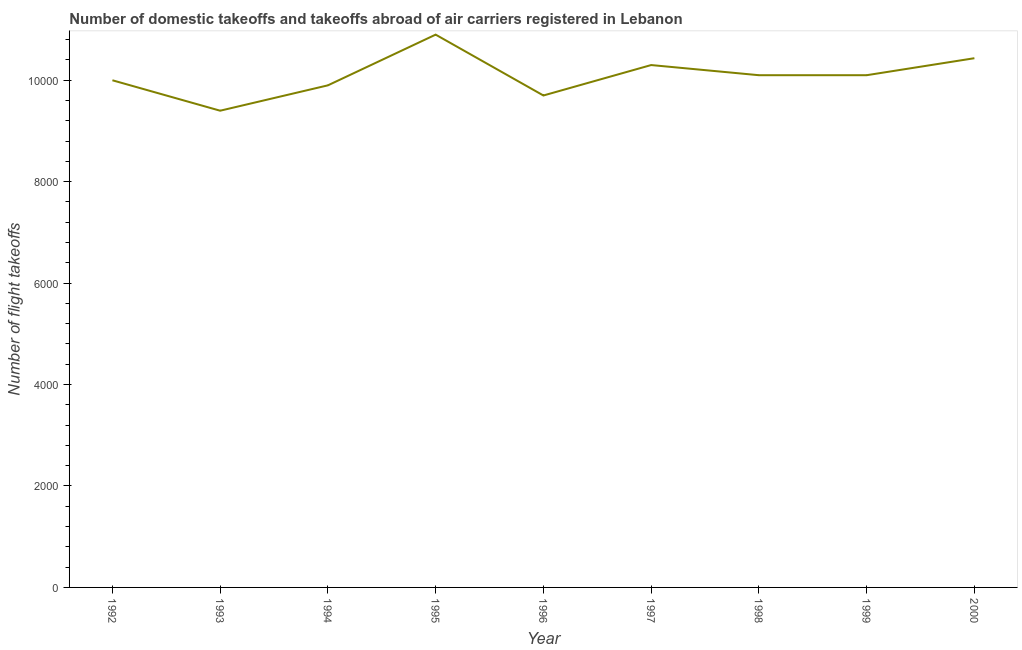What is the number of flight takeoffs in 2000?
Provide a short and direct response. 1.04e+04. Across all years, what is the maximum number of flight takeoffs?
Keep it short and to the point. 1.09e+04. Across all years, what is the minimum number of flight takeoffs?
Ensure brevity in your answer.  9400. In which year was the number of flight takeoffs maximum?
Give a very brief answer. 1995. In which year was the number of flight takeoffs minimum?
Ensure brevity in your answer.  1993. What is the sum of the number of flight takeoffs?
Your response must be concise. 9.08e+04. What is the difference between the number of flight takeoffs in 1993 and 1995?
Keep it short and to the point. -1500. What is the average number of flight takeoffs per year?
Make the answer very short. 1.01e+04. What is the median number of flight takeoffs?
Ensure brevity in your answer.  1.01e+04. Do a majority of the years between 1994 and 1992 (inclusive) have number of flight takeoffs greater than 8800 ?
Your answer should be compact. No. What is the ratio of the number of flight takeoffs in 1996 to that in 1998?
Make the answer very short. 0.96. Is the difference between the number of flight takeoffs in 1995 and 1997 greater than the difference between any two years?
Make the answer very short. No. What is the difference between the highest and the second highest number of flight takeoffs?
Ensure brevity in your answer.  465. Is the sum of the number of flight takeoffs in 1996 and 1999 greater than the maximum number of flight takeoffs across all years?
Keep it short and to the point. Yes. What is the difference between the highest and the lowest number of flight takeoffs?
Your response must be concise. 1500. Does the number of flight takeoffs monotonically increase over the years?
Offer a terse response. No. Are the values on the major ticks of Y-axis written in scientific E-notation?
Your answer should be compact. No. Does the graph contain any zero values?
Give a very brief answer. No. Does the graph contain grids?
Your answer should be compact. No. What is the title of the graph?
Provide a short and direct response. Number of domestic takeoffs and takeoffs abroad of air carriers registered in Lebanon. What is the label or title of the Y-axis?
Ensure brevity in your answer.  Number of flight takeoffs. What is the Number of flight takeoffs in 1993?
Provide a succinct answer. 9400. What is the Number of flight takeoffs of 1994?
Ensure brevity in your answer.  9900. What is the Number of flight takeoffs in 1995?
Keep it short and to the point. 1.09e+04. What is the Number of flight takeoffs in 1996?
Offer a very short reply. 9700. What is the Number of flight takeoffs of 1997?
Keep it short and to the point. 1.03e+04. What is the Number of flight takeoffs in 1998?
Provide a succinct answer. 1.01e+04. What is the Number of flight takeoffs in 1999?
Your answer should be compact. 1.01e+04. What is the Number of flight takeoffs of 2000?
Provide a short and direct response. 1.04e+04. What is the difference between the Number of flight takeoffs in 1992 and 1993?
Offer a terse response. 600. What is the difference between the Number of flight takeoffs in 1992 and 1995?
Give a very brief answer. -900. What is the difference between the Number of flight takeoffs in 1992 and 1996?
Provide a short and direct response. 300. What is the difference between the Number of flight takeoffs in 1992 and 1997?
Your answer should be very brief. -300. What is the difference between the Number of flight takeoffs in 1992 and 1998?
Make the answer very short. -100. What is the difference between the Number of flight takeoffs in 1992 and 1999?
Ensure brevity in your answer.  -100. What is the difference between the Number of flight takeoffs in 1992 and 2000?
Provide a short and direct response. -435. What is the difference between the Number of flight takeoffs in 1993 and 1994?
Give a very brief answer. -500. What is the difference between the Number of flight takeoffs in 1993 and 1995?
Make the answer very short. -1500. What is the difference between the Number of flight takeoffs in 1993 and 1996?
Give a very brief answer. -300. What is the difference between the Number of flight takeoffs in 1993 and 1997?
Offer a very short reply. -900. What is the difference between the Number of flight takeoffs in 1993 and 1998?
Offer a very short reply. -700. What is the difference between the Number of flight takeoffs in 1993 and 1999?
Your answer should be compact. -700. What is the difference between the Number of flight takeoffs in 1993 and 2000?
Offer a terse response. -1035. What is the difference between the Number of flight takeoffs in 1994 and 1995?
Offer a terse response. -1000. What is the difference between the Number of flight takeoffs in 1994 and 1997?
Your answer should be compact. -400. What is the difference between the Number of flight takeoffs in 1994 and 1998?
Offer a terse response. -200. What is the difference between the Number of flight takeoffs in 1994 and 1999?
Make the answer very short. -200. What is the difference between the Number of flight takeoffs in 1994 and 2000?
Make the answer very short. -535. What is the difference between the Number of flight takeoffs in 1995 and 1996?
Your answer should be very brief. 1200. What is the difference between the Number of flight takeoffs in 1995 and 1997?
Provide a short and direct response. 600. What is the difference between the Number of flight takeoffs in 1995 and 1998?
Keep it short and to the point. 800. What is the difference between the Number of flight takeoffs in 1995 and 1999?
Your answer should be compact. 800. What is the difference between the Number of flight takeoffs in 1995 and 2000?
Provide a short and direct response. 465. What is the difference between the Number of flight takeoffs in 1996 and 1997?
Give a very brief answer. -600. What is the difference between the Number of flight takeoffs in 1996 and 1998?
Provide a succinct answer. -400. What is the difference between the Number of flight takeoffs in 1996 and 1999?
Offer a very short reply. -400. What is the difference between the Number of flight takeoffs in 1996 and 2000?
Give a very brief answer. -735. What is the difference between the Number of flight takeoffs in 1997 and 1998?
Your answer should be compact. 200. What is the difference between the Number of flight takeoffs in 1997 and 1999?
Provide a short and direct response. 200. What is the difference between the Number of flight takeoffs in 1997 and 2000?
Your answer should be very brief. -135. What is the difference between the Number of flight takeoffs in 1998 and 1999?
Your response must be concise. 0. What is the difference between the Number of flight takeoffs in 1998 and 2000?
Your response must be concise. -335. What is the difference between the Number of flight takeoffs in 1999 and 2000?
Keep it short and to the point. -335. What is the ratio of the Number of flight takeoffs in 1992 to that in 1993?
Keep it short and to the point. 1.06. What is the ratio of the Number of flight takeoffs in 1992 to that in 1994?
Your answer should be very brief. 1.01. What is the ratio of the Number of flight takeoffs in 1992 to that in 1995?
Your answer should be very brief. 0.92. What is the ratio of the Number of flight takeoffs in 1992 to that in 1996?
Ensure brevity in your answer.  1.03. What is the ratio of the Number of flight takeoffs in 1992 to that in 1998?
Offer a very short reply. 0.99. What is the ratio of the Number of flight takeoffs in 1992 to that in 1999?
Provide a succinct answer. 0.99. What is the ratio of the Number of flight takeoffs in 1992 to that in 2000?
Your answer should be compact. 0.96. What is the ratio of the Number of flight takeoffs in 1993 to that in 1994?
Make the answer very short. 0.95. What is the ratio of the Number of flight takeoffs in 1993 to that in 1995?
Provide a succinct answer. 0.86. What is the ratio of the Number of flight takeoffs in 1993 to that in 1996?
Offer a very short reply. 0.97. What is the ratio of the Number of flight takeoffs in 1993 to that in 1998?
Provide a succinct answer. 0.93. What is the ratio of the Number of flight takeoffs in 1993 to that in 2000?
Your response must be concise. 0.9. What is the ratio of the Number of flight takeoffs in 1994 to that in 1995?
Ensure brevity in your answer.  0.91. What is the ratio of the Number of flight takeoffs in 1994 to that in 1999?
Make the answer very short. 0.98. What is the ratio of the Number of flight takeoffs in 1994 to that in 2000?
Your answer should be compact. 0.95. What is the ratio of the Number of flight takeoffs in 1995 to that in 1996?
Make the answer very short. 1.12. What is the ratio of the Number of flight takeoffs in 1995 to that in 1997?
Your answer should be very brief. 1.06. What is the ratio of the Number of flight takeoffs in 1995 to that in 1998?
Provide a succinct answer. 1.08. What is the ratio of the Number of flight takeoffs in 1995 to that in 1999?
Provide a succinct answer. 1.08. What is the ratio of the Number of flight takeoffs in 1995 to that in 2000?
Keep it short and to the point. 1.04. What is the ratio of the Number of flight takeoffs in 1996 to that in 1997?
Offer a very short reply. 0.94. What is the ratio of the Number of flight takeoffs in 1996 to that in 1999?
Your response must be concise. 0.96. What is the ratio of the Number of flight takeoffs in 1996 to that in 2000?
Your answer should be very brief. 0.93. What is the ratio of the Number of flight takeoffs in 1998 to that in 1999?
Provide a succinct answer. 1. 